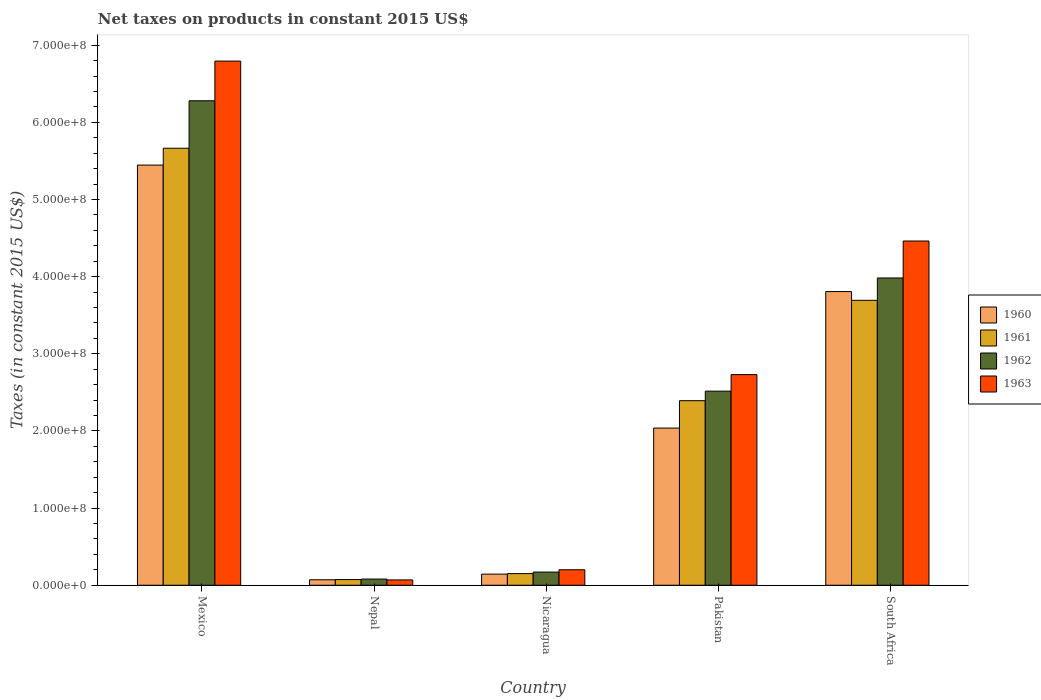Are the number of bars per tick equal to the number of legend labels?
Give a very brief answer. Yes. Are the number of bars on each tick of the X-axis equal?
Provide a short and direct response. Yes. How many bars are there on the 1st tick from the left?
Keep it short and to the point. 4. How many bars are there on the 3rd tick from the right?
Provide a succinct answer. 4. What is the label of the 5th group of bars from the left?
Your answer should be compact. South Africa. In how many cases, is the number of bars for a given country not equal to the number of legend labels?
Your answer should be very brief. 0. What is the net taxes on products in 1963 in Nicaragua?
Your answer should be very brief. 2.01e+07. Across all countries, what is the maximum net taxes on products in 1962?
Provide a succinct answer. 6.28e+08. Across all countries, what is the minimum net taxes on products in 1962?
Provide a short and direct response. 8.01e+06. In which country was the net taxes on products in 1962 minimum?
Give a very brief answer. Nepal. What is the total net taxes on products in 1961 in the graph?
Offer a very short reply. 1.20e+09. What is the difference between the net taxes on products in 1962 in Mexico and that in Pakistan?
Your response must be concise. 3.76e+08. What is the difference between the net taxes on products in 1963 in South Africa and the net taxes on products in 1962 in Nicaragua?
Your response must be concise. 4.29e+08. What is the average net taxes on products in 1960 per country?
Keep it short and to the point. 2.30e+08. What is the difference between the net taxes on products of/in 1963 and net taxes on products of/in 1961 in Mexico?
Offer a very short reply. 1.13e+08. What is the ratio of the net taxes on products in 1961 in Pakistan to that in South Africa?
Your answer should be compact. 0.65. Is the difference between the net taxes on products in 1963 in Nepal and Pakistan greater than the difference between the net taxes on products in 1961 in Nepal and Pakistan?
Your answer should be compact. No. What is the difference between the highest and the second highest net taxes on products in 1963?
Your response must be concise. 4.06e+08. What is the difference between the highest and the lowest net taxes on products in 1963?
Make the answer very short. 6.72e+08. In how many countries, is the net taxes on products in 1961 greater than the average net taxes on products in 1961 taken over all countries?
Ensure brevity in your answer.  2. Is the sum of the net taxes on products in 1961 in Nicaragua and South Africa greater than the maximum net taxes on products in 1963 across all countries?
Offer a terse response. No. What does the 2nd bar from the right in South Africa represents?
Your response must be concise. 1962. How many bars are there?
Offer a very short reply. 20. How many countries are there in the graph?
Offer a very short reply. 5. Does the graph contain grids?
Provide a short and direct response. No. How are the legend labels stacked?
Your answer should be very brief. Vertical. What is the title of the graph?
Your response must be concise. Net taxes on products in constant 2015 US$. What is the label or title of the X-axis?
Offer a very short reply. Country. What is the label or title of the Y-axis?
Offer a terse response. Taxes (in constant 2015 US$). What is the Taxes (in constant 2015 US$) of 1960 in Mexico?
Make the answer very short. 5.45e+08. What is the Taxes (in constant 2015 US$) of 1961 in Mexico?
Ensure brevity in your answer.  5.66e+08. What is the Taxes (in constant 2015 US$) of 1962 in Mexico?
Ensure brevity in your answer.  6.28e+08. What is the Taxes (in constant 2015 US$) of 1963 in Mexico?
Provide a short and direct response. 6.79e+08. What is the Taxes (in constant 2015 US$) in 1960 in Nepal?
Your answer should be compact. 7.09e+06. What is the Taxes (in constant 2015 US$) of 1961 in Nepal?
Provide a short and direct response. 7.35e+06. What is the Taxes (in constant 2015 US$) of 1962 in Nepal?
Your response must be concise. 8.01e+06. What is the Taxes (in constant 2015 US$) of 1963 in Nepal?
Make the answer very short. 6.89e+06. What is the Taxes (in constant 2015 US$) of 1960 in Nicaragua?
Your answer should be compact. 1.44e+07. What is the Taxes (in constant 2015 US$) in 1961 in Nicaragua?
Ensure brevity in your answer.  1.51e+07. What is the Taxes (in constant 2015 US$) in 1962 in Nicaragua?
Provide a succinct answer. 1.71e+07. What is the Taxes (in constant 2015 US$) of 1963 in Nicaragua?
Give a very brief answer. 2.01e+07. What is the Taxes (in constant 2015 US$) of 1960 in Pakistan?
Ensure brevity in your answer.  2.04e+08. What is the Taxes (in constant 2015 US$) of 1961 in Pakistan?
Offer a terse response. 2.39e+08. What is the Taxes (in constant 2015 US$) in 1962 in Pakistan?
Provide a short and direct response. 2.52e+08. What is the Taxes (in constant 2015 US$) of 1963 in Pakistan?
Offer a very short reply. 2.73e+08. What is the Taxes (in constant 2015 US$) in 1960 in South Africa?
Make the answer very short. 3.81e+08. What is the Taxes (in constant 2015 US$) of 1961 in South Africa?
Provide a short and direct response. 3.69e+08. What is the Taxes (in constant 2015 US$) of 1962 in South Africa?
Offer a very short reply. 3.98e+08. What is the Taxes (in constant 2015 US$) in 1963 in South Africa?
Your answer should be compact. 4.46e+08. Across all countries, what is the maximum Taxes (in constant 2015 US$) in 1960?
Make the answer very short. 5.45e+08. Across all countries, what is the maximum Taxes (in constant 2015 US$) in 1961?
Ensure brevity in your answer.  5.66e+08. Across all countries, what is the maximum Taxes (in constant 2015 US$) of 1962?
Make the answer very short. 6.28e+08. Across all countries, what is the maximum Taxes (in constant 2015 US$) in 1963?
Provide a succinct answer. 6.79e+08. Across all countries, what is the minimum Taxes (in constant 2015 US$) of 1960?
Give a very brief answer. 7.09e+06. Across all countries, what is the minimum Taxes (in constant 2015 US$) in 1961?
Your answer should be compact. 7.35e+06. Across all countries, what is the minimum Taxes (in constant 2015 US$) of 1962?
Make the answer very short. 8.01e+06. Across all countries, what is the minimum Taxes (in constant 2015 US$) in 1963?
Make the answer very short. 6.89e+06. What is the total Taxes (in constant 2015 US$) in 1960 in the graph?
Ensure brevity in your answer.  1.15e+09. What is the total Taxes (in constant 2015 US$) in 1961 in the graph?
Keep it short and to the point. 1.20e+09. What is the total Taxes (in constant 2015 US$) of 1962 in the graph?
Provide a short and direct response. 1.30e+09. What is the total Taxes (in constant 2015 US$) of 1963 in the graph?
Give a very brief answer. 1.43e+09. What is the difference between the Taxes (in constant 2015 US$) of 1960 in Mexico and that in Nepal?
Offer a terse response. 5.37e+08. What is the difference between the Taxes (in constant 2015 US$) in 1961 in Mexico and that in Nepal?
Your answer should be very brief. 5.59e+08. What is the difference between the Taxes (in constant 2015 US$) in 1962 in Mexico and that in Nepal?
Your answer should be very brief. 6.20e+08. What is the difference between the Taxes (in constant 2015 US$) in 1963 in Mexico and that in Nepal?
Offer a very short reply. 6.72e+08. What is the difference between the Taxes (in constant 2015 US$) of 1960 in Mexico and that in Nicaragua?
Ensure brevity in your answer.  5.30e+08. What is the difference between the Taxes (in constant 2015 US$) in 1961 in Mexico and that in Nicaragua?
Your answer should be very brief. 5.51e+08. What is the difference between the Taxes (in constant 2015 US$) of 1962 in Mexico and that in Nicaragua?
Your answer should be very brief. 6.11e+08. What is the difference between the Taxes (in constant 2015 US$) of 1963 in Mexico and that in Nicaragua?
Your answer should be very brief. 6.59e+08. What is the difference between the Taxes (in constant 2015 US$) of 1960 in Mexico and that in Pakistan?
Your answer should be very brief. 3.41e+08. What is the difference between the Taxes (in constant 2015 US$) of 1961 in Mexico and that in Pakistan?
Keep it short and to the point. 3.27e+08. What is the difference between the Taxes (in constant 2015 US$) in 1962 in Mexico and that in Pakistan?
Ensure brevity in your answer.  3.76e+08. What is the difference between the Taxes (in constant 2015 US$) in 1963 in Mexico and that in Pakistan?
Provide a succinct answer. 4.06e+08. What is the difference between the Taxes (in constant 2015 US$) in 1960 in Mexico and that in South Africa?
Provide a succinct answer. 1.64e+08. What is the difference between the Taxes (in constant 2015 US$) of 1961 in Mexico and that in South Africa?
Your answer should be compact. 1.97e+08. What is the difference between the Taxes (in constant 2015 US$) of 1962 in Mexico and that in South Africa?
Offer a terse response. 2.30e+08. What is the difference between the Taxes (in constant 2015 US$) in 1963 in Mexico and that in South Africa?
Give a very brief answer. 2.33e+08. What is the difference between the Taxes (in constant 2015 US$) in 1960 in Nepal and that in Nicaragua?
Your answer should be compact. -7.30e+06. What is the difference between the Taxes (in constant 2015 US$) in 1961 in Nepal and that in Nicaragua?
Your response must be concise. -7.71e+06. What is the difference between the Taxes (in constant 2015 US$) in 1962 in Nepal and that in Nicaragua?
Your answer should be very brief. -9.06e+06. What is the difference between the Taxes (in constant 2015 US$) of 1963 in Nepal and that in Nicaragua?
Offer a very short reply. -1.32e+07. What is the difference between the Taxes (in constant 2015 US$) of 1960 in Nepal and that in Pakistan?
Offer a terse response. -1.97e+08. What is the difference between the Taxes (in constant 2015 US$) in 1961 in Nepal and that in Pakistan?
Your answer should be very brief. -2.32e+08. What is the difference between the Taxes (in constant 2015 US$) of 1962 in Nepal and that in Pakistan?
Your answer should be compact. -2.44e+08. What is the difference between the Taxes (in constant 2015 US$) in 1963 in Nepal and that in Pakistan?
Keep it short and to the point. -2.66e+08. What is the difference between the Taxes (in constant 2015 US$) in 1960 in Nepal and that in South Africa?
Provide a succinct answer. -3.74e+08. What is the difference between the Taxes (in constant 2015 US$) of 1961 in Nepal and that in South Africa?
Ensure brevity in your answer.  -3.62e+08. What is the difference between the Taxes (in constant 2015 US$) of 1962 in Nepal and that in South Africa?
Offer a very short reply. -3.90e+08. What is the difference between the Taxes (in constant 2015 US$) of 1963 in Nepal and that in South Africa?
Provide a short and direct response. -4.39e+08. What is the difference between the Taxes (in constant 2015 US$) in 1960 in Nicaragua and that in Pakistan?
Your response must be concise. -1.89e+08. What is the difference between the Taxes (in constant 2015 US$) of 1961 in Nicaragua and that in Pakistan?
Your answer should be compact. -2.24e+08. What is the difference between the Taxes (in constant 2015 US$) of 1962 in Nicaragua and that in Pakistan?
Ensure brevity in your answer.  -2.35e+08. What is the difference between the Taxes (in constant 2015 US$) of 1963 in Nicaragua and that in Pakistan?
Keep it short and to the point. -2.53e+08. What is the difference between the Taxes (in constant 2015 US$) in 1960 in Nicaragua and that in South Africa?
Offer a very short reply. -3.66e+08. What is the difference between the Taxes (in constant 2015 US$) of 1961 in Nicaragua and that in South Africa?
Give a very brief answer. -3.54e+08. What is the difference between the Taxes (in constant 2015 US$) in 1962 in Nicaragua and that in South Africa?
Keep it short and to the point. -3.81e+08. What is the difference between the Taxes (in constant 2015 US$) in 1963 in Nicaragua and that in South Africa?
Your response must be concise. -4.26e+08. What is the difference between the Taxes (in constant 2015 US$) in 1960 in Pakistan and that in South Africa?
Your response must be concise. -1.77e+08. What is the difference between the Taxes (in constant 2015 US$) in 1961 in Pakistan and that in South Africa?
Offer a very short reply. -1.30e+08. What is the difference between the Taxes (in constant 2015 US$) in 1962 in Pakistan and that in South Africa?
Provide a short and direct response. -1.47e+08. What is the difference between the Taxes (in constant 2015 US$) in 1963 in Pakistan and that in South Africa?
Make the answer very short. -1.73e+08. What is the difference between the Taxes (in constant 2015 US$) of 1960 in Mexico and the Taxes (in constant 2015 US$) of 1961 in Nepal?
Your response must be concise. 5.37e+08. What is the difference between the Taxes (in constant 2015 US$) in 1960 in Mexico and the Taxes (in constant 2015 US$) in 1962 in Nepal?
Make the answer very short. 5.37e+08. What is the difference between the Taxes (in constant 2015 US$) in 1960 in Mexico and the Taxes (in constant 2015 US$) in 1963 in Nepal?
Ensure brevity in your answer.  5.38e+08. What is the difference between the Taxes (in constant 2015 US$) in 1961 in Mexico and the Taxes (in constant 2015 US$) in 1962 in Nepal?
Make the answer very short. 5.58e+08. What is the difference between the Taxes (in constant 2015 US$) of 1961 in Mexico and the Taxes (in constant 2015 US$) of 1963 in Nepal?
Provide a succinct answer. 5.60e+08. What is the difference between the Taxes (in constant 2015 US$) of 1962 in Mexico and the Taxes (in constant 2015 US$) of 1963 in Nepal?
Provide a succinct answer. 6.21e+08. What is the difference between the Taxes (in constant 2015 US$) in 1960 in Mexico and the Taxes (in constant 2015 US$) in 1961 in Nicaragua?
Offer a terse response. 5.30e+08. What is the difference between the Taxes (in constant 2015 US$) of 1960 in Mexico and the Taxes (in constant 2015 US$) of 1962 in Nicaragua?
Offer a very short reply. 5.28e+08. What is the difference between the Taxes (in constant 2015 US$) in 1960 in Mexico and the Taxes (in constant 2015 US$) in 1963 in Nicaragua?
Ensure brevity in your answer.  5.24e+08. What is the difference between the Taxes (in constant 2015 US$) in 1961 in Mexico and the Taxes (in constant 2015 US$) in 1962 in Nicaragua?
Make the answer very short. 5.49e+08. What is the difference between the Taxes (in constant 2015 US$) of 1961 in Mexico and the Taxes (in constant 2015 US$) of 1963 in Nicaragua?
Keep it short and to the point. 5.46e+08. What is the difference between the Taxes (in constant 2015 US$) in 1962 in Mexico and the Taxes (in constant 2015 US$) in 1963 in Nicaragua?
Ensure brevity in your answer.  6.08e+08. What is the difference between the Taxes (in constant 2015 US$) of 1960 in Mexico and the Taxes (in constant 2015 US$) of 1961 in Pakistan?
Your response must be concise. 3.05e+08. What is the difference between the Taxes (in constant 2015 US$) of 1960 in Mexico and the Taxes (in constant 2015 US$) of 1962 in Pakistan?
Offer a very short reply. 2.93e+08. What is the difference between the Taxes (in constant 2015 US$) of 1960 in Mexico and the Taxes (in constant 2015 US$) of 1963 in Pakistan?
Offer a terse response. 2.72e+08. What is the difference between the Taxes (in constant 2015 US$) of 1961 in Mexico and the Taxes (in constant 2015 US$) of 1962 in Pakistan?
Your answer should be compact. 3.15e+08. What is the difference between the Taxes (in constant 2015 US$) of 1961 in Mexico and the Taxes (in constant 2015 US$) of 1963 in Pakistan?
Provide a succinct answer. 2.93e+08. What is the difference between the Taxes (in constant 2015 US$) of 1962 in Mexico and the Taxes (in constant 2015 US$) of 1963 in Pakistan?
Offer a very short reply. 3.55e+08. What is the difference between the Taxes (in constant 2015 US$) in 1960 in Mexico and the Taxes (in constant 2015 US$) in 1961 in South Africa?
Keep it short and to the point. 1.75e+08. What is the difference between the Taxes (in constant 2015 US$) in 1960 in Mexico and the Taxes (in constant 2015 US$) in 1962 in South Africa?
Your response must be concise. 1.46e+08. What is the difference between the Taxes (in constant 2015 US$) of 1960 in Mexico and the Taxes (in constant 2015 US$) of 1963 in South Africa?
Your answer should be very brief. 9.84e+07. What is the difference between the Taxes (in constant 2015 US$) of 1961 in Mexico and the Taxes (in constant 2015 US$) of 1962 in South Africa?
Offer a very short reply. 1.68e+08. What is the difference between the Taxes (in constant 2015 US$) in 1961 in Mexico and the Taxes (in constant 2015 US$) in 1963 in South Africa?
Your answer should be compact. 1.20e+08. What is the difference between the Taxes (in constant 2015 US$) in 1962 in Mexico and the Taxes (in constant 2015 US$) in 1963 in South Africa?
Ensure brevity in your answer.  1.82e+08. What is the difference between the Taxes (in constant 2015 US$) of 1960 in Nepal and the Taxes (in constant 2015 US$) of 1961 in Nicaragua?
Your answer should be compact. -7.97e+06. What is the difference between the Taxes (in constant 2015 US$) in 1960 in Nepal and the Taxes (in constant 2015 US$) in 1962 in Nicaragua?
Ensure brevity in your answer.  -9.98e+06. What is the difference between the Taxes (in constant 2015 US$) of 1960 in Nepal and the Taxes (in constant 2015 US$) of 1963 in Nicaragua?
Offer a very short reply. -1.30e+07. What is the difference between the Taxes (in constant 2015 US$) in 1961 in Nepal and the Taxes (in constant 2015 US$) in 1962 in Nicaragua?
Offer a very short reply. -9.71e+06. What is the difference between the Taxes (in constant 2015 US$) of 1961 in Nepal and the Taxes (in constant 2015 US$) of 1963 in Nicaragua?
Your response must be concise. -1.27e+07. What is the difference between the Taxes (in constant 2015 US$) of 1962 in Nepal and the Taxes (in constant 2015 US$) of 1963 in Nicaragua?
Your response must be concise. -1.21e+07. What is the difference between the Taxes (in constant 2015 US$) in 1960 in Nepal and the Taxes (in constant 2015 US$) in 1961 in Pakistan?
Make the answer very short. -2.32e+08. What is the difference between the Taxes (in constant 2015 US$) in 1960 in Nepal and the Taxes (in constant 2015 US$) in 1962 in Pakistan?
Offer a terse response. -2.44e+08. What is the difference between the Taxes (in constant 2015 US$) in 1960 in Nepal and the Taxes (in constant 2015 US$) in 1963 in Pakistan?
Offer a very short reply. -2.66e+08. What is the difference between the Taxes (in constant 2015 US$) in 1961 in Nepal and the Taxes (in constant 2015 US$) in 1962 in Pakistan?
Offer a very short reply. -2.44e+08. What is the difference between the Taxes (in constant 2015 US$) in 1961 in Nepal and the Taxes (in constant 2015 US$) in 1963 in Pakistan?
Give a very brief answer. -2.66e+08. What is the difference between the Taxes (in constant 2015 US$) of 1962 in Nepal and the Taxes (in constant 2015 US$) of 1963 in Pakistan?
Your response must be concise. -2.65e+08. What is the difference between the Taxes (in constant 2015 US$) in 1960 in Nepal and the Taxes (in constant 2015 US$) in 1961 in South Africa?
Offer a very short reply. -3.62e+08. What is the difference between the Taxes (in constant 2015 US$) of 1960 in Nepal and the Taxes (in constant 2015 US$) of 1962 in South Africa?
Provide a short and direct response. -3.91e+08. What is the difference between the Taxes (in constant 2015 US$) of 1960 in Nepal and the Taxes (in constant 2015 US$) of 1963 in South Africa?
Give a very brief answer. -4.39e+08. What is the difference between the Taxes (in constant 2015 US$) in 1961 in Nepal and the Taxes (in constant 2015 US$) in 1962 in South Africa?
Keep it short and to the point. -3.91e+08. What is the difference between the Taxes (in constant 2015 US$) of 1961 in Nepal and the Taxes (in constant 2015 US$) of 1963 in South Africa?
Your answer should be compact. -4.39e+08. What is the difference between the Taxes (in constant 2015 US$) in 1962 in Nepal and the Taxes (in constant 2015 US$) in 1963 in South Africa?
Your response must be concise. -4.38e+08. What is the difference between the Taxes (in constant 2015 US$) in 1960 in Nicaragua and the Taxes (in constant 2015 US$) in 1961 in Pakistan?
Your response must be concise. -2.25e+08. What is the difference between the Taxes (in constant 2015 US$) in 1960 in Nicaragua and the Taxes (in constant 2015 US$) in 1962 in Pakistan?
Your response must be concise. -2.37e+08. What is the difference between the Taxes (in constant 2015 US$) of 1960 in Nicaragua and the Taxes (in constant 2015 US$) of 1963 in Pakistan?
Offer a terse response. -2.59e+08. What is the difference between the Taxes (in constant 2015 US$) in 1961 in Nicaragua and the Taxes (in constant 2015 US$) in 1962 in Pakistan?
Your response must be concise. -2.37e+08. What is the difference between the Taxes (in constant 2015 US$) of 1961 in Nicaragua and the Taxes (in constant 2015 US$) of 1963 in Pakistan?
Keep it short and to the point. -2.58e+08. What is the difference between the Taxes (in constant 2015 US$) of 1962 in Nicaragua and the Taxes (in constant 2015 US$) of 1963 in Pakistan?
Give a very brief answer. -2.56e+08. What is the difference between the Taxes (in constant 2015 US$) of 1960 in Nicaragua and the Taxes (in constant 2015 US$) of 1961 in South Africa?
Keep it short and to the point. -3.55e+08. What is the difference between the Taxes (in constant 2015 US$) in 1960 in Nicaragua and the Taxes (in constant 2015 US$) in 1962 in South Africa?
Your response must be concise. -3.84e+08. What is the difference between the Taxes (in constant 2015 US$) in 1960 in Nicaragua and the Taxes (in constant 2015 US$) in 1963 in South Africa?
Give a very brief answer. -4.32e+08. What is the difference between the Taxes (in constant 2015 US$) in 1961 in Nicaragua and the Taxes (in constant 2015 US$) in 1962 in South Africa?
Offer a terse response. -3.83e+08. What is the difference between the Taxes (in constant 2015 US$) of 1961 in Nicaragua and the Taxes (in constant 2015 US$) of 1963 in South Africa?
Your response must be concise. -4.31e+08. What is the difference between the Taxes (in constant 2015 US$) in 1962 in Nicaragua and the Taxes (in constant 2015 US$) in 1963 in South Africa?
Offer a terse response. -4.29e+08. What is the difference between the Taxes (in constant 2015 US$) in 1960 in Pakistan and the Taxes (in constant 2015 US$) in 1961 in South Africa?
Provide a succinct answer. -1.66e+08. What is the difference between the Taxes (in constant 2015 US$) of 1960 in Pakistan and the Taxes (in constant 2015 US$) of 1962 in South Africa?
Ensure brevity in your answer.  -1.95e+08. What is the difference between the Taxes (in constant 2015 US$) in 1960 in Pakistan and the Taxes (in constant 2015 US$) in 1963 in South Africa?
Make the answer very short. -2.42e+08. What is the difference between the Taxes (in constant 2015 US$) of 1961 in Pakistan and the Taxes (in constant 2015 US$) of 1962 in South Africa?
Offer a very short reply. -1.59e+08. What is the difference between the Taxes (in constant 2015 US$) of 1961 in Pakistan and the Taxes (in constant 2015 US$) of 1963 in South Africa?
Keep it short and to the point. -2.07e+08. What is the difference between the Taxes (in constant 2015 US$) of 1962 in Pakistan and the Taxes (in constant 2015 US$) of 1963 in South Africa?
Your response must be concise. -1.95e+08. What is the average Taxes (in constant 2015 US$) in 1960 per country?
Offer a terse response. 2.30e+08. What is the average Taxes (in constant 2015 US$) in 1961 per country?
Your response must be concise. 2.39e+08. What is the average Taxes (in constant 2015 US$) of 1962 per country?
Your answer should be compact. 2.61e+08. What is the average Taxes (in constant 2015 US$) in 1963 per country?
Provide a short and direct response. 2.85e+08. What is the difference between the Taxes (in constant 2015 US$) of 1960 and Taxes (in constant 2015 US$) of 1961 in Mexico?
Make the answer very short. -2.18e+07. What is the difference between the Taxes (in constant 2015 US$) in 1960 and Taxes (in constant 2015 US$) in 1962 in Mexico?
Your answer should be very brief. -8.34e+07. What is the difference between the Taxes (in constant 2015 US$) in 1960 and Taxes (in constant 2015 US$) in 1963 in Mexico?
Keep it short and to the point. -1.35e+08. What is the difference between the Taxes (in constant 2015 US$) in 1961 and Taxes (in constant 2015 US$) in 1962 in Mexico?
Make the answer very short. -6.15e+07. What is the difference between the Taxes (in constant 2015 US$) in 1961 and Taxes (in constant 2015 US$) in 1963 in Mexico?
Offer a terse response. -1.13e+08. What is the difference between the Taxes (in constant 2015 US$) in 1962 and Taxes (in constant 2015 US$) in 1963 in Mexico?
Offer a terse response. -5.14e+07. What is the difference between the Taxes (in constant 2015 US$) of 1960 and Taxes (in constant 2015 US$) of 1961 in Nepal?
Provide a succinct answer. -2.63e+05. What is the difference between the Taxes (in constant 2015 US$) in 1960 and Taxes (in constant 2015 US$) in 1962 in Nepal?
Make the answer very short. -9.19e+05. What is the difference between the Taxes (in constant 2015 US$) in 1960 and Taxes (in constant 2015 US$) in 1963 in Nepal?
Your response must be concise. 1.97e+05. What is the difference between the Taxes (in constant 2015 US$) of 1961 and Taxes (in constant 2015 US$) of 1962 in Nepal?
Offer a very short reply. -6.56e+05. What is the difference between the Taxes (in constant 2015 US$) of 1961 and Taxes (in constant 2015 US$) of 1963 in Nepal?
Offer a terse response. 4.60e+05. What is the difference between the Taxes (in constant 2015 US$) of 1962 and Taxes (in constant 2015 US$) of 1963 in Nepal?
Make the answer very short. 1.12e+06. What is the difference between the Taxes (in constant 2015 US$) of 1960 and Taxes (in constant 2015 US$) of 1961 in Nicaragua?
Ensure brevity in your answer.  -6.69e+05. What is the difference between the Taxes (in constant 2015 US$) of 1960 and Taxes (in constant 2015 US$) of 1962 in Nicaragua?
Make the answer very short. -2.68e+06. What is the difference between the Taxes (in constant 2015 US$) in 1960 and Taxes (in constant 2015 US$) in 1963 in Nicaragua?
Provide a short and direct response. -5.69e+06. What is the difference between the Taxes (in constant 2015 US$) of 1961 and Taxes (in constant 2015 US$) of 1962 in Nicaragua?
Your answer should be compact. -2.01e+06. What is the difference between the Taxes (in constant 2015 US$) in 1961 and Taxes (in constant 2015 US$) in 1963 in Nicaragua?
Give a very brief answer. -5.02e+06. What is the difference between the Taxes (in constant 2015 US$) of 1962 and Taxes (in constant 2015 US$) of 1963 in Nicaragua?
Offer a very short reply. -3.01e+06. What is the difference between the Taxes (in constant 2015 US$) in 1960 and Taxes (in constant 2015 US$) in 1961 in Pakistan?
Keep it short and to the point. -3.55e+07. What is the difference between the Taxes (in constant 2015 US$) in 1960 and Taxes (in constant 2015 US$) in 1962 in Pakistan?
Your response must be concise. -4.79e+07. What is the difference between the Taxes (in constant 2015 US$) in 1960 and Taxes (in constant 2015 US$) in 1963 in Pakistan?
Make the answer very short. -6.93e+07. What is the difference between the Taxes (in constant 2015 US$) in 1961 and Taxes (in constant 2015 US$) in 1962 in Pakistan?
Offer a very short reply. -1.24e+07. What is the difference between the Taxes (in constant 2015 US$) of 1961 and Taxes (in constant 2015 US$) of 1963 in Pakistan?
Make the answer very short. -3.38e+07. What is the difference between the Taxes (in constant 2015 US$) in 1962 and Taxes (in constant 2015 US$) in 1963 in Pakistan?
Offer a very short reply. -2.14e+07. What is the difference between the Taxes (in constant 2015 US$) in 1960 and Taxes (in constant 2015 US$) in 1961 in South Africa?
Ensure brevity in your answer.  1.13e+07. What is the difference between the Taxes (in constant 2015 US$) in 1960 and Taxes (in constant 2015 US$) in 1962 in South Africa?
Ensure brevity in your answer.  -1.76e+07. What is the difference between the Taxes (in constant 2015 US$) in 1960 and Taxes (in constant 2015 US$) in 1963 in South Africa?
Your answer should be very brief. -6.55e+07. What is the difference between the Taxes (in constant 2015 US$) of 1961 and Taxes (in constant 2015 US$) of 1962 in South Africa?
Your answer should be very brief. -2.90e+07. What is the difference between the Taxes (in constant 2015 US$) of 1961 and Taxes (in constant 2015 US$) of 1963 in South Africa?
Your answer should be compact. -7.69e+07. What is the difference between the Taxes (in constant 2015 US$) of 1962 and Taxes (in constant 2015 US$) of 1963 in South Africa?
Your answer should be very brief. -4.79e+07. What is the ratio of the Taxes (in constant 2015 US$) of 1960 in Mexico to that in Nepal?
Ensure brevity in your answer.  76.83. What is the ratio of the Taxes (in constant 2015 US$) in 1961 in Mexico to that in Nepal?
Keep it short and to the point. 77.06. What is the ratio of the Taxes (in constant 2015 US$) of 1962 in Mexico to that in Nepal?
Make the answer very short. 78.43. What is the ratio of the Taxes (in constant 2015 US$) of 1963 in Mexico to that in Nepal?
Offer a terse response. 98.6. What is the ratio of the Taxes (in constant 2015 US$) of 1960 in Mexico to that in Nicaragua?
Ensure brevity in your answer.  37.85. What is the ratio of the Taxes (in constant 2015 US$) in 1961 in Mexico to that in Nicaragua?
Offer a very short reply. 37.62. What is the ratio of the Taxes (in constant 2015 US$) of 1962 in Mexico to that in Nicaragua?
Your answer should be compact. 36.8. What is the ratio of the Taxes (in constant 2015 US$) of 1963 in Mexico to that in Nicaragua?
Offer a terse response. 33.84. What is the ratio of the Taxes (in constant 2015 US$) in 1960 in Mexico to that in Pakistan?
Ensure brevity in your answer.  2.67. What is the ratio of the Taxes (in constant 2015 US$) of 1961 in Mexico to that in Pakistan?
Give a very brief answer. 2.37. What is the ratio of the Taxes (in constant 2015 US$) of 1962 in Mexico to that in Pakistan?
Your response must be concise. 2.5. What is the ratio of the Taxes (in constant 2015 US$) of 1963 in Mexico to that in Pakistan?
Your answer should be very brief. 2.49. What is the ratio of the Taxes (in constant 2015 US$) of 1960 in Mexico to that in South Africa?
Ensure brevity in your answer.  1.43. What is the ratio of the Taxes (in constant 2015 US$) of 1961 in Mexico to that in South Africa?
Make the answer very short. 1.53. What is the ratio of the Taxes (in constant 2015 US$) of 1962 in Mexico to that in South Africa?
Your answer should be very brief. 1.58. What is the ratio of the Taxes (in constant 2015 US$) in 1963 in Mexico to that in South Africa?
Keep it short and to the point. 1.52. What is the ratio of the Taxes (in constant 2015 US$) of 1960 in Nepal to that in Nicaragua?
Make the answer very short. 0.49. What is the ratio of the Taxes (in constant 2015 US$) of 1961 in Nepal to that in Nicaragua?
Provide a succinct answer. 0.49. What is the ratio of the Taxes (in constant 2015 US$) of 1962 in Nepal to that in Nicaragua?
Give a very brief answer. 0.47. What is the ratio of the Taxes (in constant 2015 US$) in 1963 in Nepal to that in Nicaragua?
Your answer should be compact. 0.34. What is the ratio of the Taxes (in constant 2015 US$) of 1960 in Nepal to that in Pakistan?
Ensure brevity in your answer.  0.03. What is the ratio of the Taxes (in constant 2015 US$) of 1961 in Nepal to that in Pakistan?
Give a very brief answer. 0.03. What is the ratio of the Taxes (in constant 2015 US$) in 1962 in Nepal to that in Pakistan?
Provide a succinct answer. 0.03. What is the ratio of the Taxes (in constant 2015 US$) in 1963 in Nepal to that in Pakistan?
Your answer should be compact. 0.03. What is the ratio of the Taxes (in constant 2015 US$) of 1960 in Nepal to that in South Africa?
Give a very brief answer. 0.02. What is the ratio of the Taxes (in constant 2015 US$) in 1961 in Nepal to that in South Africa?
Provide a short and direct response. 0.02. What is the ratio of the Taxes (in constant 2015 US$) in 1962 in Nepal to that in South Africa?
Offer a terse response. 0.02. What is the ratio of the Taxes (in constant 2015 US$) of 1963 in Nepal to that in South Africa?
Make the answer very short. 0.02. What is the ratio of the Taxes (in constant 2015 US$) in 1960 in Nicaragua to that in Pakistan?
Your answer should be compact. 0.07. What is the ratio of the Taxes (in constant 2015 US$) in 1961 in Nicaragua to that in Pakistan?
Provide a succinct answer. 0.06. What is the ratio of the Taxes (in constant 2015 US$) in 1962 in Nicaragua to that in Pakistan?
Ensure brevity in your answer.  0.07. What is the ratio of the Taxes (in constant 2015 US$) in 1963 in Nicaragua to that in Pakistan?
Ensure brevity in your answer.  0.07. What is the ratio of the Taxes (in constant 2015 US$) in 1960 in Nicaragua to that in South Africa?
Provide a succinct answer. 0.04. What is the ratio of the Taxes (in constant 2015 US$) of 1961 in Nicaragua to that in South Africa?
Your response must be concise. 0.04. What is the ratio of the Taxes (in constant 2015 US$) in 1962 in Nicaragua to that in South Africa?
Your response must be concise. 0.04. What is the ratio of the Taxes (in constant 2015 US$) in 1963 in Nicaragua to that in South Africa?
Keep it short and to the point. 0.04. What is the ratio of the Taxes (in constant 2015 US$) in 1960 in Pakistan to that in South Africa?
Provide a short and direct response. 0.54. What is the ratio of the Taxes (in constant 2015 US$) of 1961 in Pakistan to that in South Africa?
Your answer should be very brief. 0.65. What is the ratio of the Taxes (in constant 2015 US$) in 1962 in Pakistan to that in South Africa?
Your answer should be compact. 0.63. What is the ratio of the Taxes (in constant 2015 US$) in 1963 in Pakistan to that in South Africa?
Keep it short and to the point. 0.61. What is the difference between the highest and the second highest Taxes (in constant 2015 US$) in 1960?
Keep it short and to the point. 1.64e+08. What is the difference between the highest and the second highest Taxes (in constant 2015 US$) of 1961?
Give a very brief answer. 1.97e+08. What is the difference between the highest and the second highest Taxes (in constant 2015 US$) of 1962?
Provide a short and direct response. 2.30e+08. What is the difference between the highest and the second highest Taxes (in constant 2015 US$) of 1963?
Offer a terse response. 2.33e+08. What is the difference between the highest and the lowest Taxes (in constant 2015 US$) of 1960?
Your answer should be very brief. 5.37e+08. What is the difference between the highest and the lowest Taxes (in constant 2015 US$) of 1961?
Your answer should be very brief. 5.59e+08. What is the difference between the highest and the lowest Taxes (in constant 2015 US$) of 1962?
Give a very brief answer. 6.20e+08. What is the difference between the highest and the lowest Taxes (in constant 2015 US$) in 1963?
Ensure brevity in your answer.  6.72e+08. 